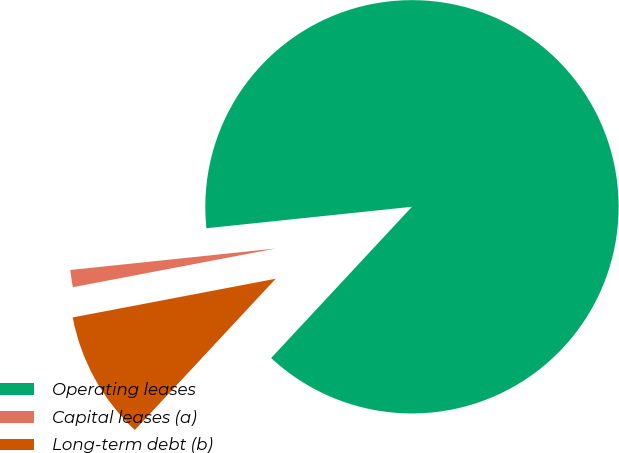Convert chart. <chart><loc_0><loc_0><loc_500><loc_500><pie_chart><fcel>Operating leases<fcel>Capital leases (a)<fcel>Long-term debt (b)<nl><fcel>88.59%<fcel>1.34%<fcel>10.07%<nl></chart> 